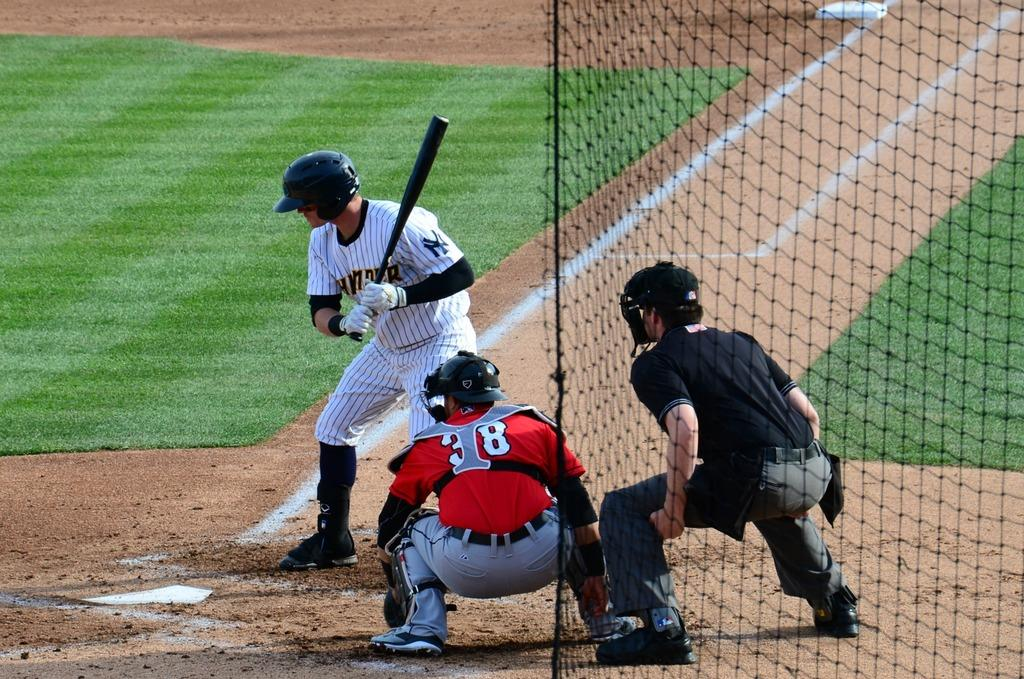How many people are in the image? There are three persons in the image. What are the persons wearing on their heads? The persons are wearing helmets. Which person is holding a bat? The person with gloves is holding a bat. What is present on the right side of the image? There is a net on the right side of the image. What type of surface is visible on the ground in the image? There is grass on the ground in the image. How many rabbits can be seen in the image? There are no rabbits present in the image. What is the person's desire to increase their performance in the image? There is no information about the person's desire or performance in the image. 